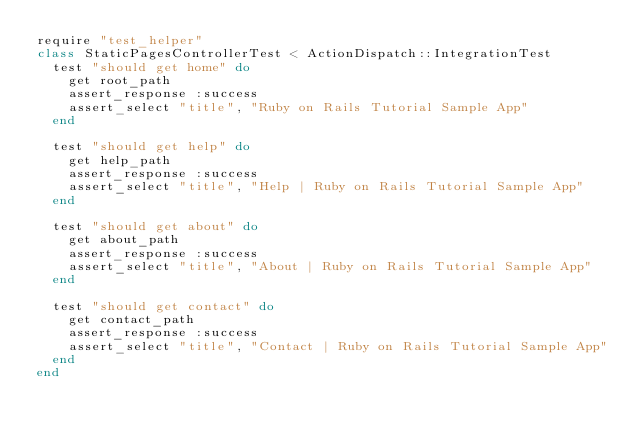<code> <loc_0><loc_0><loc_500><loc_500><_Ruby_>require "test_helper"
class StaticPagesControllerTest < ActionDispatch::IntegrationTest
  test "should get home" do
    get root_path
    assert_response :success
    assert_select "title", "Ruby on Rails Tutorial Sample App"
  end

  test "should get help" do
    get help_path
    assert_response :success
    assert_select "title", "Help | Ruby on Rails Tutorial Sample App"
  end

  test "should get about" do
    get about_path
    assert_response :success
    assert_select "title", "About | Ruby on Rails Tutorial Sample App"
  end

  test "should get contact" do
    get contact_path
    assert_response :success
    assert_select "title", "Contact | Ruby on Rails Tutorial Sample App"
  end
end
</code> 